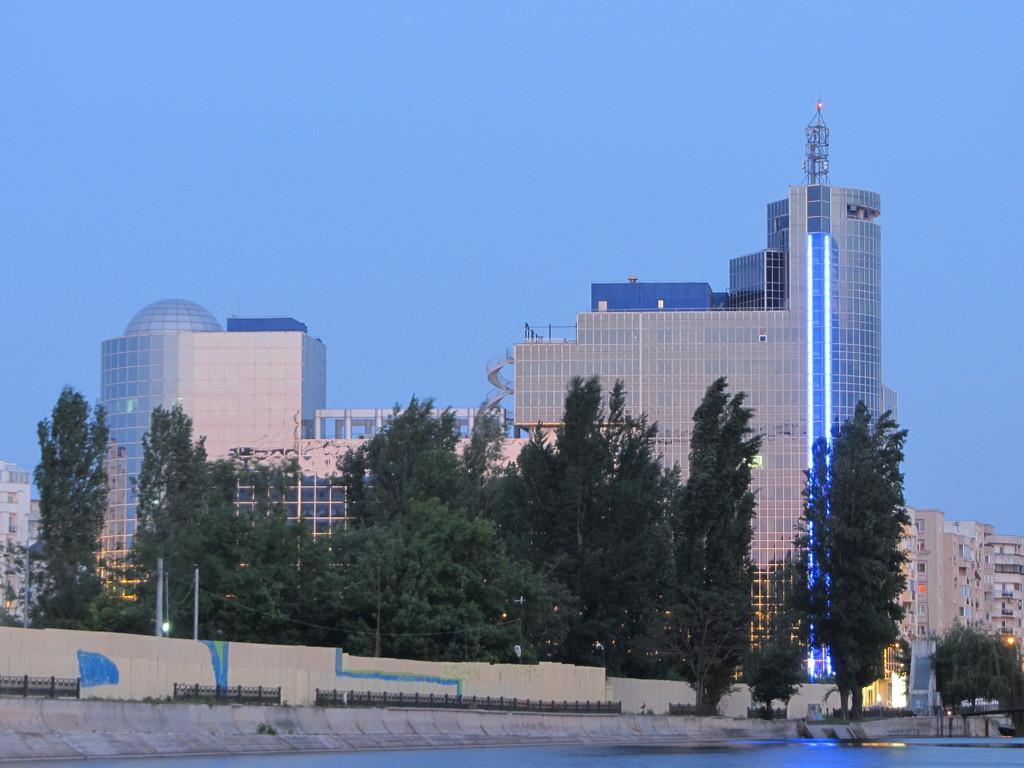Can you describe this image briefly? In this picture I can see few buildings and few trees and a blue sky and I can see water. 